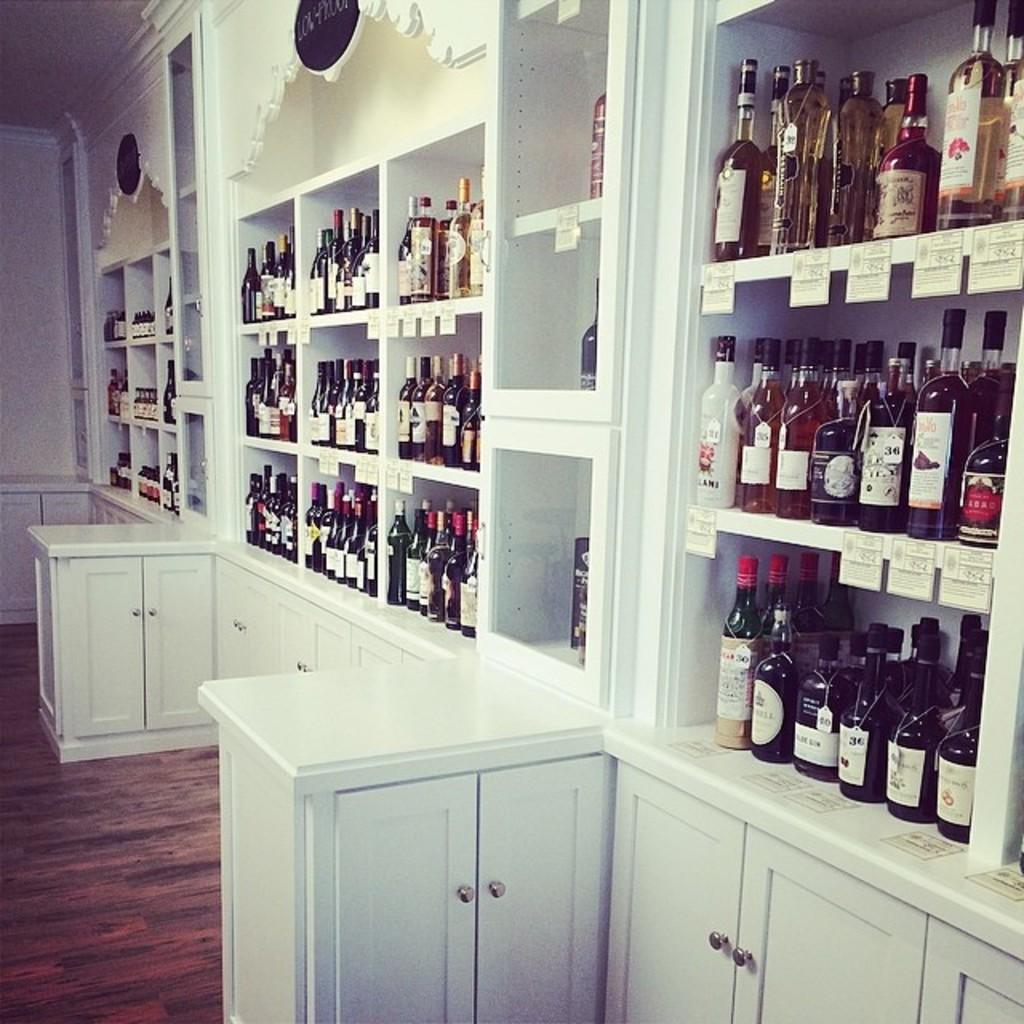What type of furniture is located in the center of the image? There are cupboards and racks in the center of the image. What items can be seen on the cupboards and racks? There are wine bottles and banners in the center of the image. What can be seen in the background of the image? There is a wall and a roof in the background of the image. Where is the dock located in the image? There is no dock present in the image. What type of building is shown in the image? The image does not show a building; it features cupboards, racks, wine bottles, and banners. 